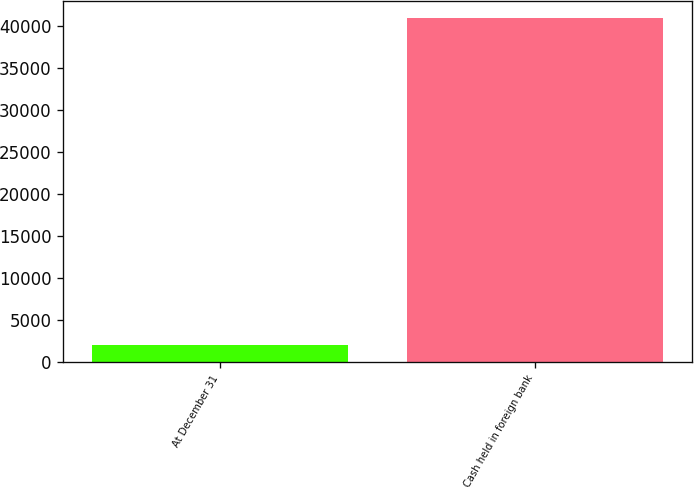<chart> <loc_0><loc_0><loc_500><loc_500><bar_chart><fcel>At December 31<fcel>Cash held in foreign bank<nl><fcel>2012<fcel>40933<nl></chart> 